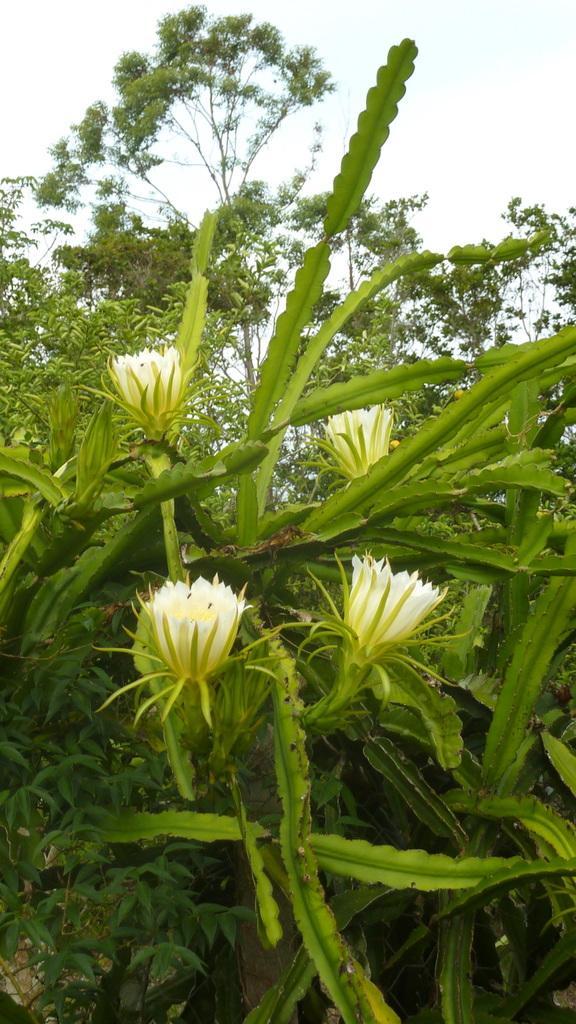Describe this image in one or two sentences. In this image there are few flowers, trees and the sky. 